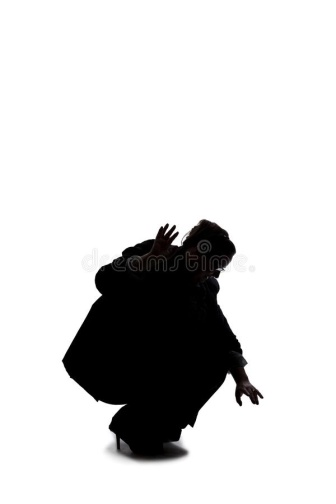Based on the person’s pose and position, create a short realistic scenario explaining what they might be doing. The person in the image is participating in an intense theatrical performance. They are portraying a character trapped in a moment of suspense and desperation. Crouched low with arms extended, the actor is depicting a fugitive hiding from pursuers. The stark white background represents the blinding interrogation lights shining down on them, heightening the drama and tension of the scene. Every muscle in their body is tense, ready to spring into action at a moment's notice, their silhouette casting a striking figure on the blank canvas, embodying the intense emotions of the character they are playing. 